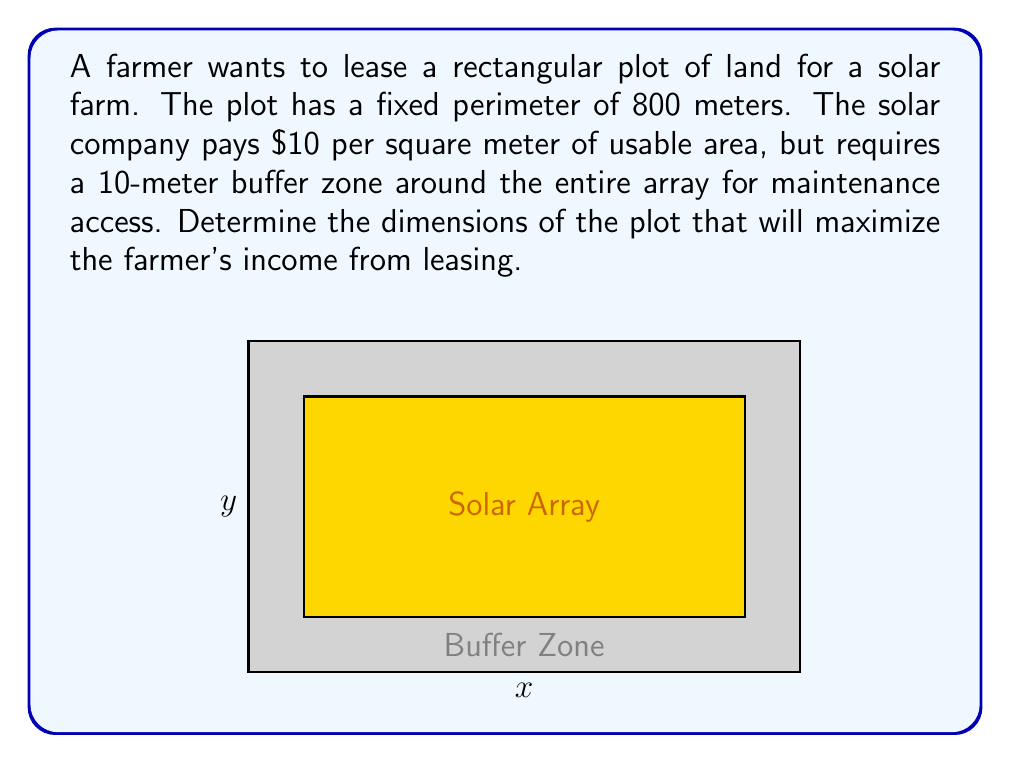What is the answer to this math problem? Let's approach this step-by-step:

1) Let $x$ and $y$ be the length and width of the plot in meters.

2) Given the perimeter is fixed at 800 meters:
   $$2x + 2y = 800$$
   $$y = 400 - x$$

3) The usable area for solar panels will be $(x-20)(y-20)$, accounting for the 10-meter buffer on each side.

4) The income function $I(x)$ is:
   $$I(x) = 10(x-20)(y-20)$$
   $$I(x) = 10(x-20)(400-x-20)$$
   $$I(x) = 10(x-20)(380-x)$$

5) Expanding this:
   $$I(x) = 10(380x - x^2 - 7600 + 20x)$$
   $$I(x) = 10(400x - x^2 - 7600)$$
   $$I(x) = 4000x - 10x^2 - 76000$$

6) To find the maximum, we differentiate and set to zero:
   $$\frac{dI}{dx} = 4000 - 20x = 0$$
   $$20x = 4000$$
   $$x = 200$$

7) The second derivative is negative (-20), confirming this is a maximum.

8) With $x = 200$, we can find $y$:
   $$y = 400 - 200 = 200$$

Therefore, the optimal dimensions are 200m by 200m.
Answer: 200m x 200m 